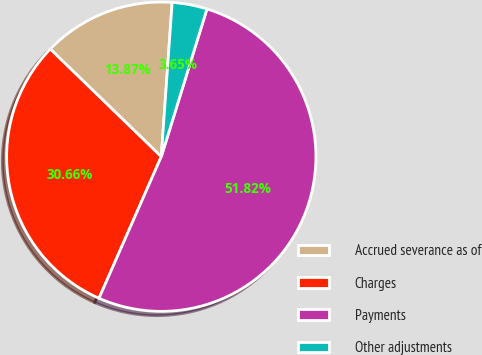Convert chart to OTSL. <chart><loc_0><loc_0><loc_500><loc_500><pie_chart><fcel>Accrued severance as of<fcel>Charges<fcel>Payments<fcel>Other adjustments<nl><fcel>13.87%<fcel>30.66%<fcel>51.82%<fcel>3.65%<nl></chart> 